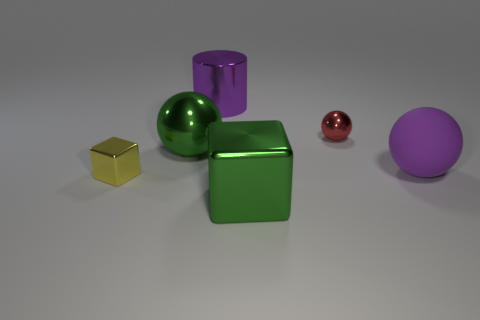Add 3 green metal cubes. How many objects exist? 9 Subtract all blocks. How many objects are left? 4 Add 1 small blocks. How many small blocks exist? 2 Subtract 0 cyan cubes. How many objects are left? 6 Subtract all yellow shiny blocks. Subtract all small red shiny things. How many objects are left? 4 Add 2 large metal spheres. How many large metal spheres are left? 3 